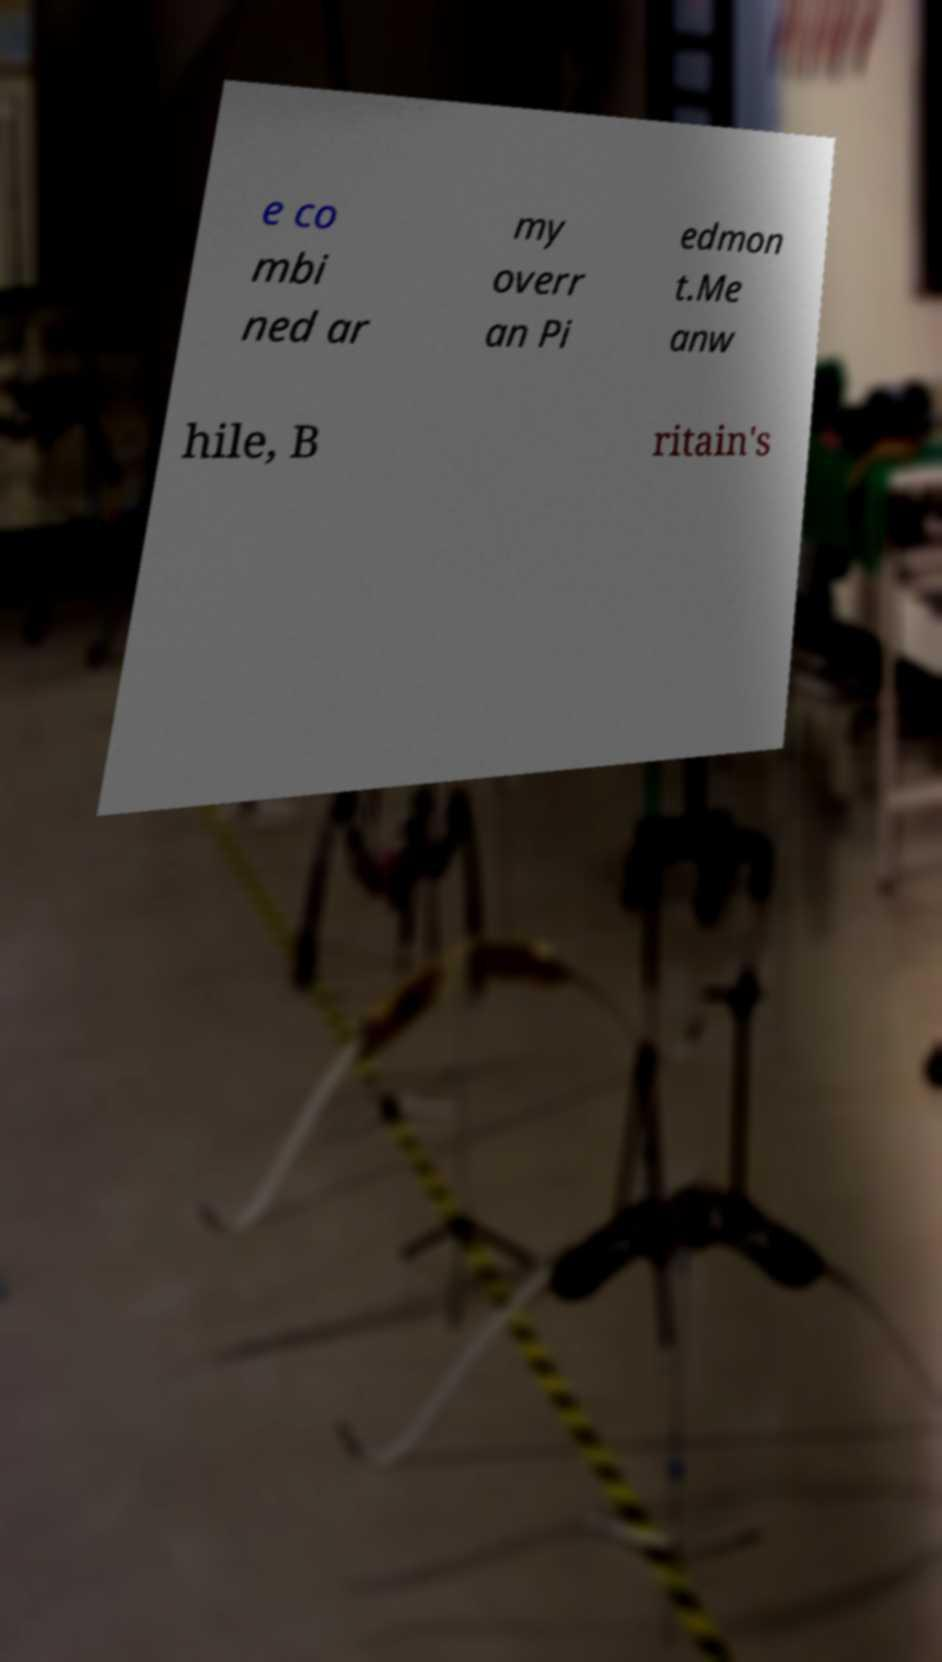I need the written content from this picture converted into text. Can you do that? e co mbi ned ar my overr an Pi edmon t.Me anw hile, B ritain's 